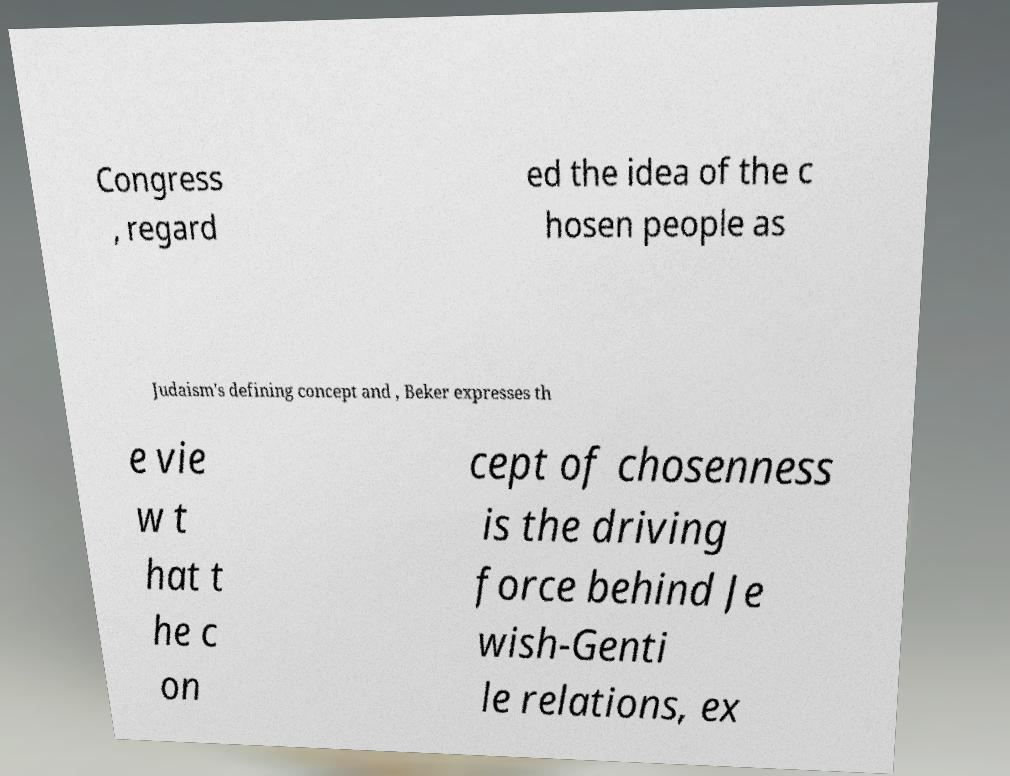Please identify and transcribe the text found in this image. Congress , regard ed the idea of the c hosen people as Judaism's defining concept and , Beker expresses th e vie w t hat t he c on cept of chosenness is the driving force behind Je wish-Genti le relations, ex 